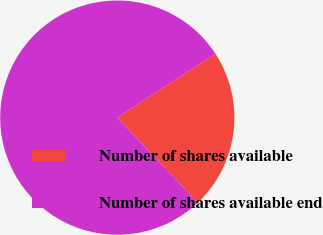Convert chart to OTSL. <chart><loc_0><loc_0><loc_500><loc_500><pie_chart><fcel>Number of shares available<fcel>Number of shares available end<nl><fcel>22.14%<fcel>77.86%<nl></chart> 